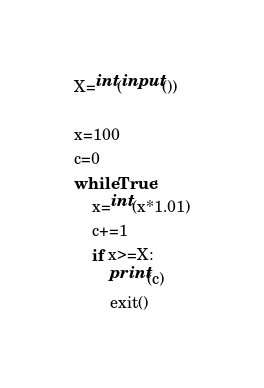Convert code to text. <code><loc_0><loc_0><loc_500><loc_500><_Python_>X=int(input())

x=100
c=0
while True:
    x=int(x*1.01)
    c+=1
    if x>=X:
        print(c)
        exit()</code> 